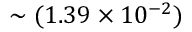<formula> <loc_0><loc_0><loc_500><loc_500>\sim ( 1 . 3 9 \times 1 0 ^ { - 2 } )</formula> 